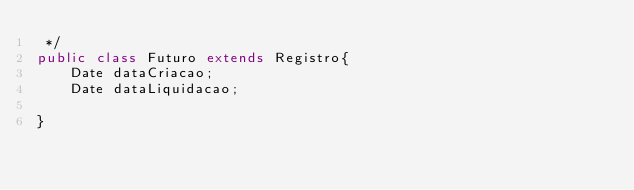<code> <loc_0><loc_0><loc_500><loc_500><_Java_> */
public class Futuro extends Registro{
    Date dataCriacao;
    Date dataLiquidacao;
    
}
</code> 